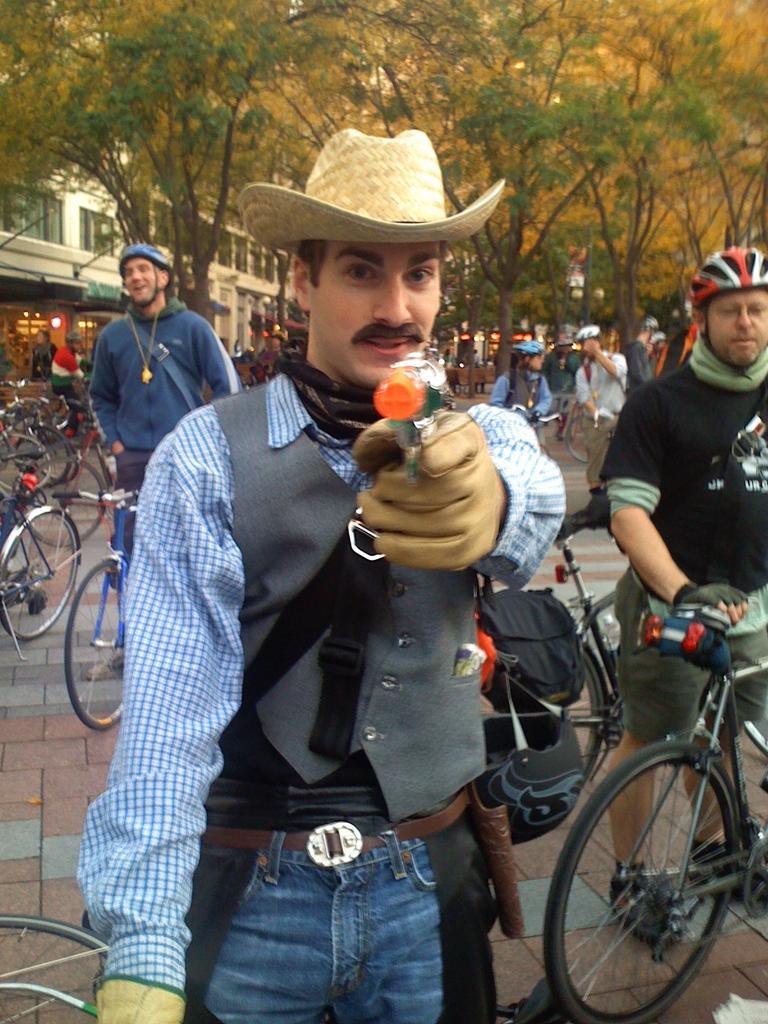Could you give a brief overview of what you see in this image? In this picture I can see group of people are standing on the ground. Here I can see a man is wearing a hat and holding an object in the hand. In the background I can see bicycles, trees and buildings. Some people are wearing helmets. 